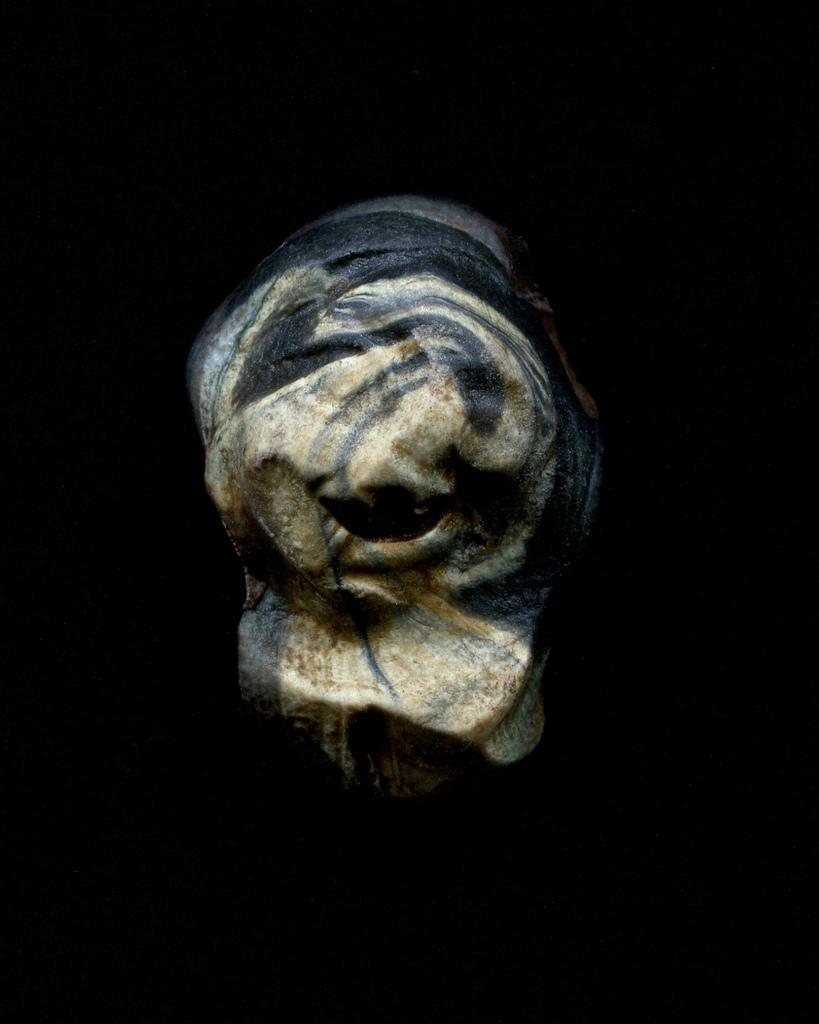How would you summarize this image in a sentence or two? In this picture we can see a sculpture and there is a dark background. 